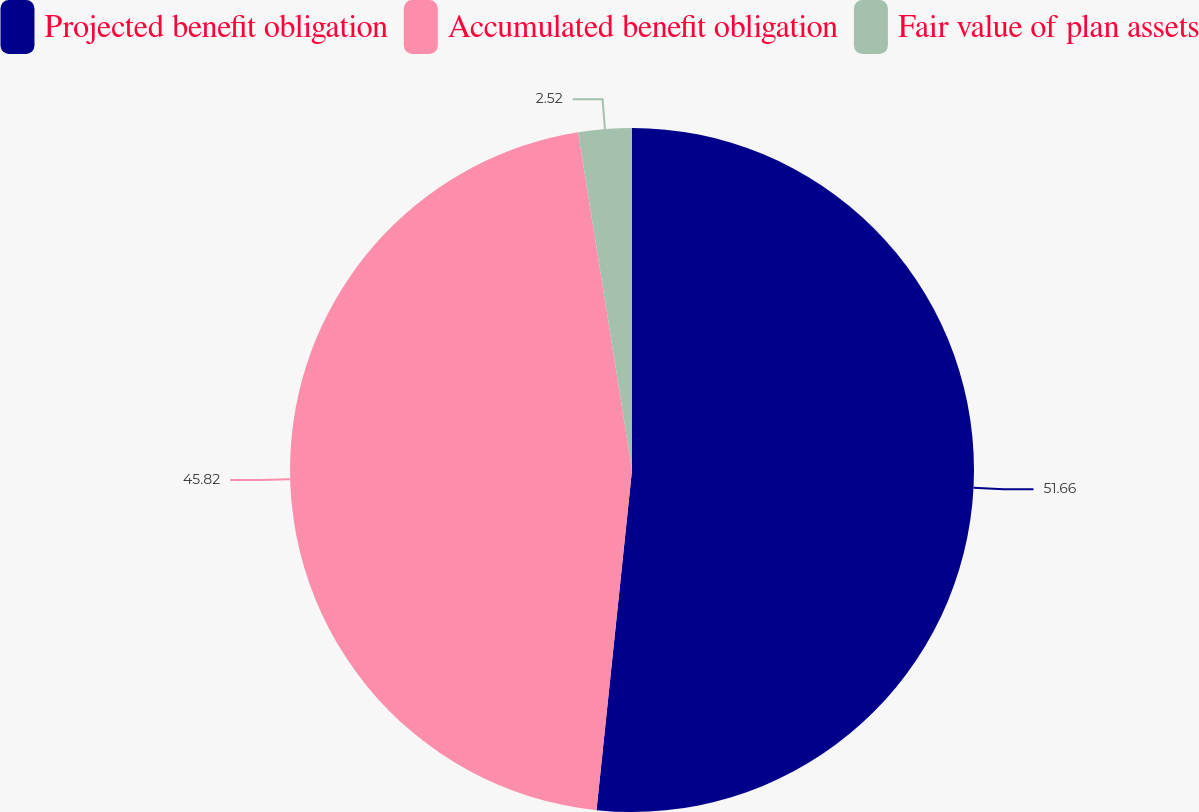<chart> <loc_0><loc_0><loc_500><loc_500><pie_chart><fcel>Projected benefit obligation<fcel>Accumulated benefit obligation<fcel>Fair value of plan assets<nl><fcel>51.65%<fcel>45.82%<fcel>2.52%<nl></chart> 